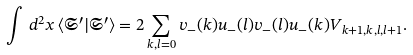<formula> <loc_0><loc_0><loc_500><loc_500>\int \, d ^ { 2 } x \, \langle \mathfrak { S } ^ { \prime } | \mathfrak { S } ^ { \prime } \rangle = 2 \sum _ { k , l = 0 } v _ { - } ( k ) u _ { - } ( l ) v _ { - } ( l ) u _ { - } ( k ) V _ { k + 1 , k , l , l + 1 } .</formula> 